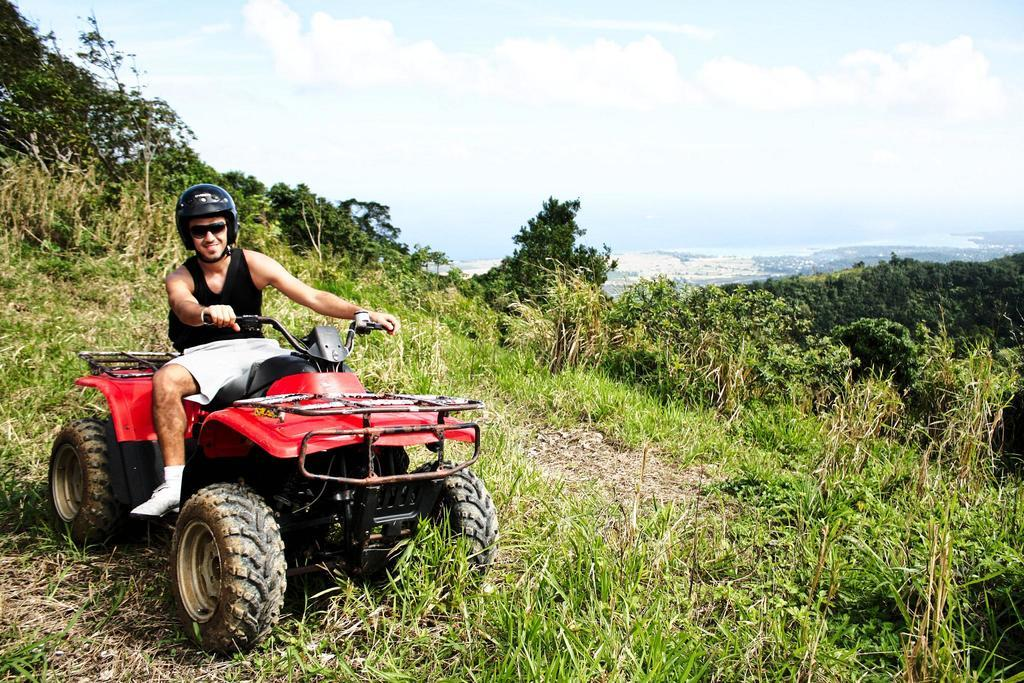What is the position of the man in the image? The man is on the left side of the image. What is the man doing in the image? The man is seated on a vehicle. What accessories is the man wearing in the image? The man is wearing spectacles and a helmet. What can be seen in the background of the image? There are plants, trees, and clouds in the background of the image. What type of nerve is the man using to say good-bye in the image? There is no indication in the image that the man is saying good-bye or using any specific nerve to communicate. 